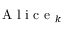Convert formula to latex. <formula><loc_0><loc_0><loc_500><loc_500>A l i c e _ { k }</formula> 